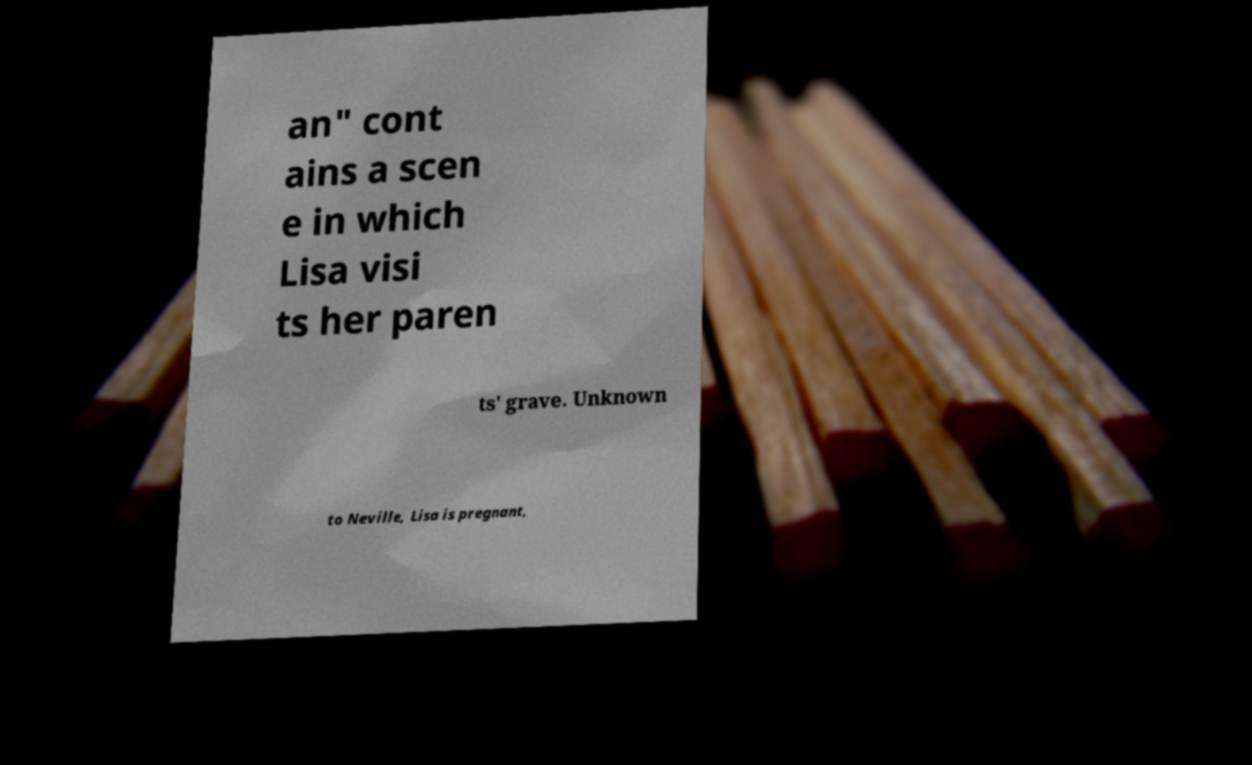What messages or text are displayed in this image? I need them in a readable, typed format. an" cont ains a scen e in which Lisa visi ts her paren ts' grave. Unknown to Neville, Lisa is pregnant, 